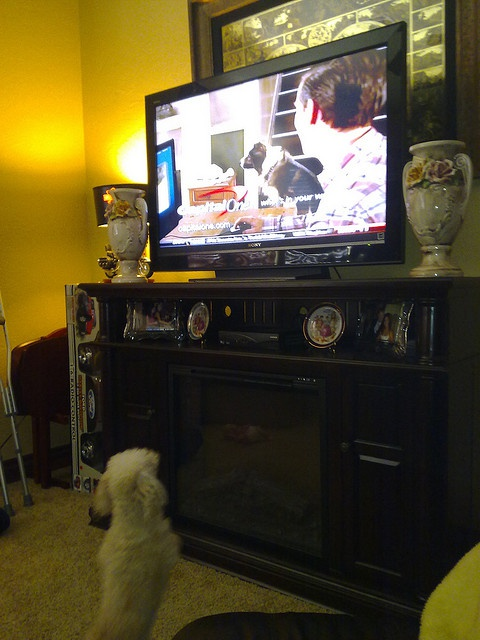Describe the objects in this image and their specific colors. I can see tv in olive, white, black, gray, and darkgray tones, people in olive, white, gray, and purple tones, dog in olive and black tones, vase in olive, darkgreen, black, and gray tones, and vase in olive and gray tones in this image. 